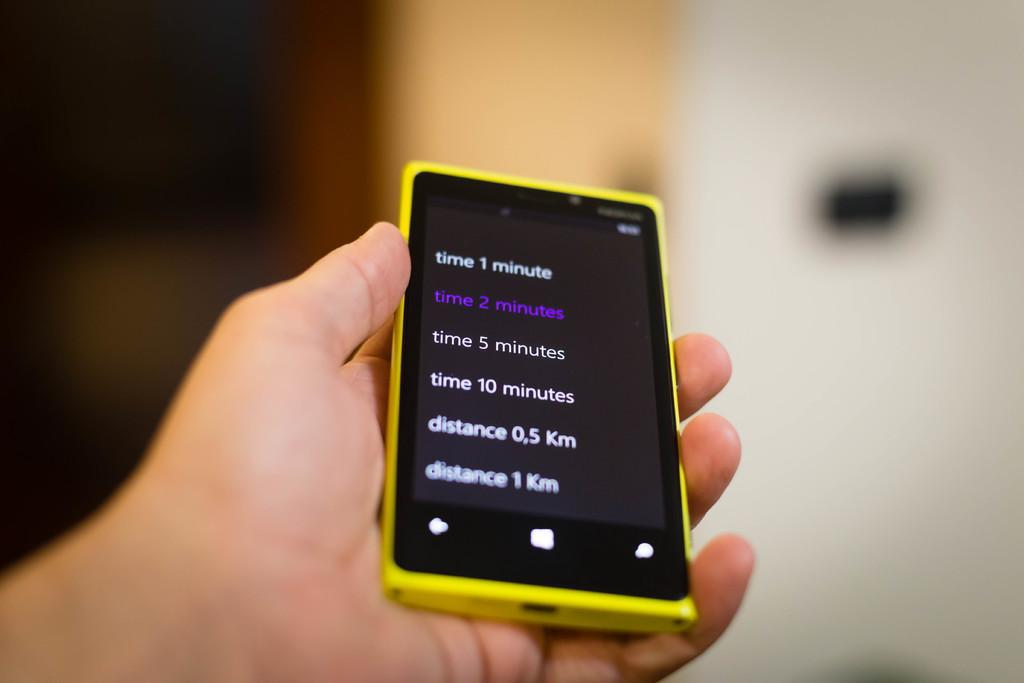<image>
Relay a brief, clear account of the picture shown. A hand holds up a phone with the display showing times and distances. 